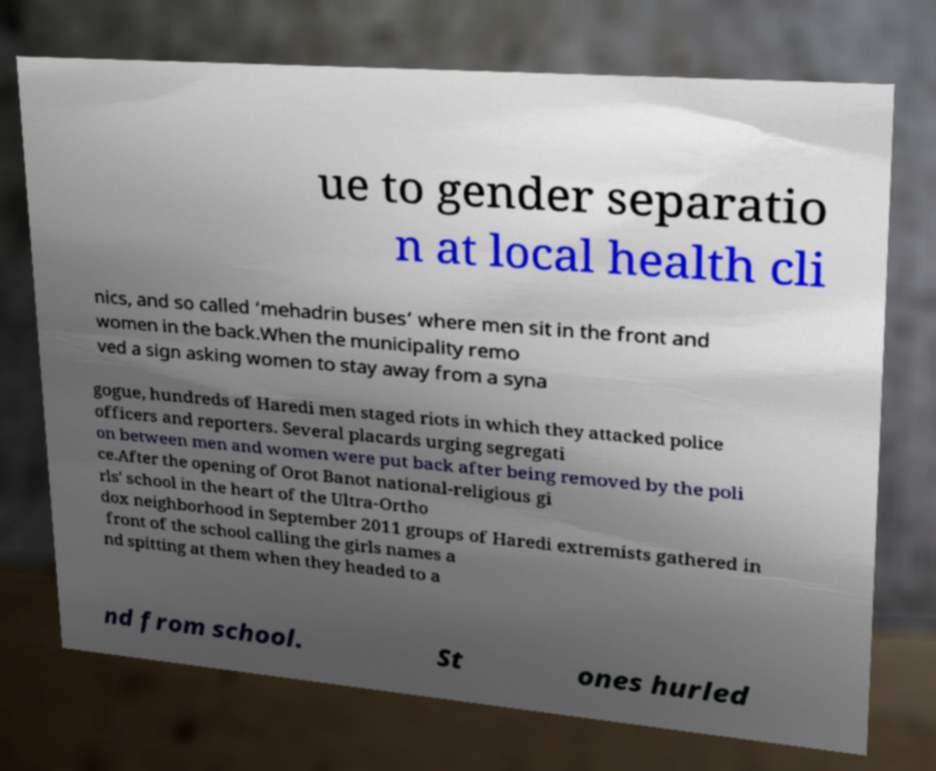Can you accurately transcribe the text from the provided image for me? ue to gender separatio n at local health cli nics, and so called ‘mehadrin buses’ where men sit in the front and women in the back.When the municipality remo ved a sign asking women to stay away from a syna gogue, hundreds of Haredi men staged riots in which they attacked police officers and reporters. Several placards urging segregati on between men and women were put back after being removed by the poli ce.After the opening of Orot Banot national-religious gi rls' school in the heart of the Ultra-Ortho dox neighborhood in September 2011 groups of Haredi extremists gathered in front of the school calling the girls names a nd spitting at them when they headed to a nd from school. St ones hurled 